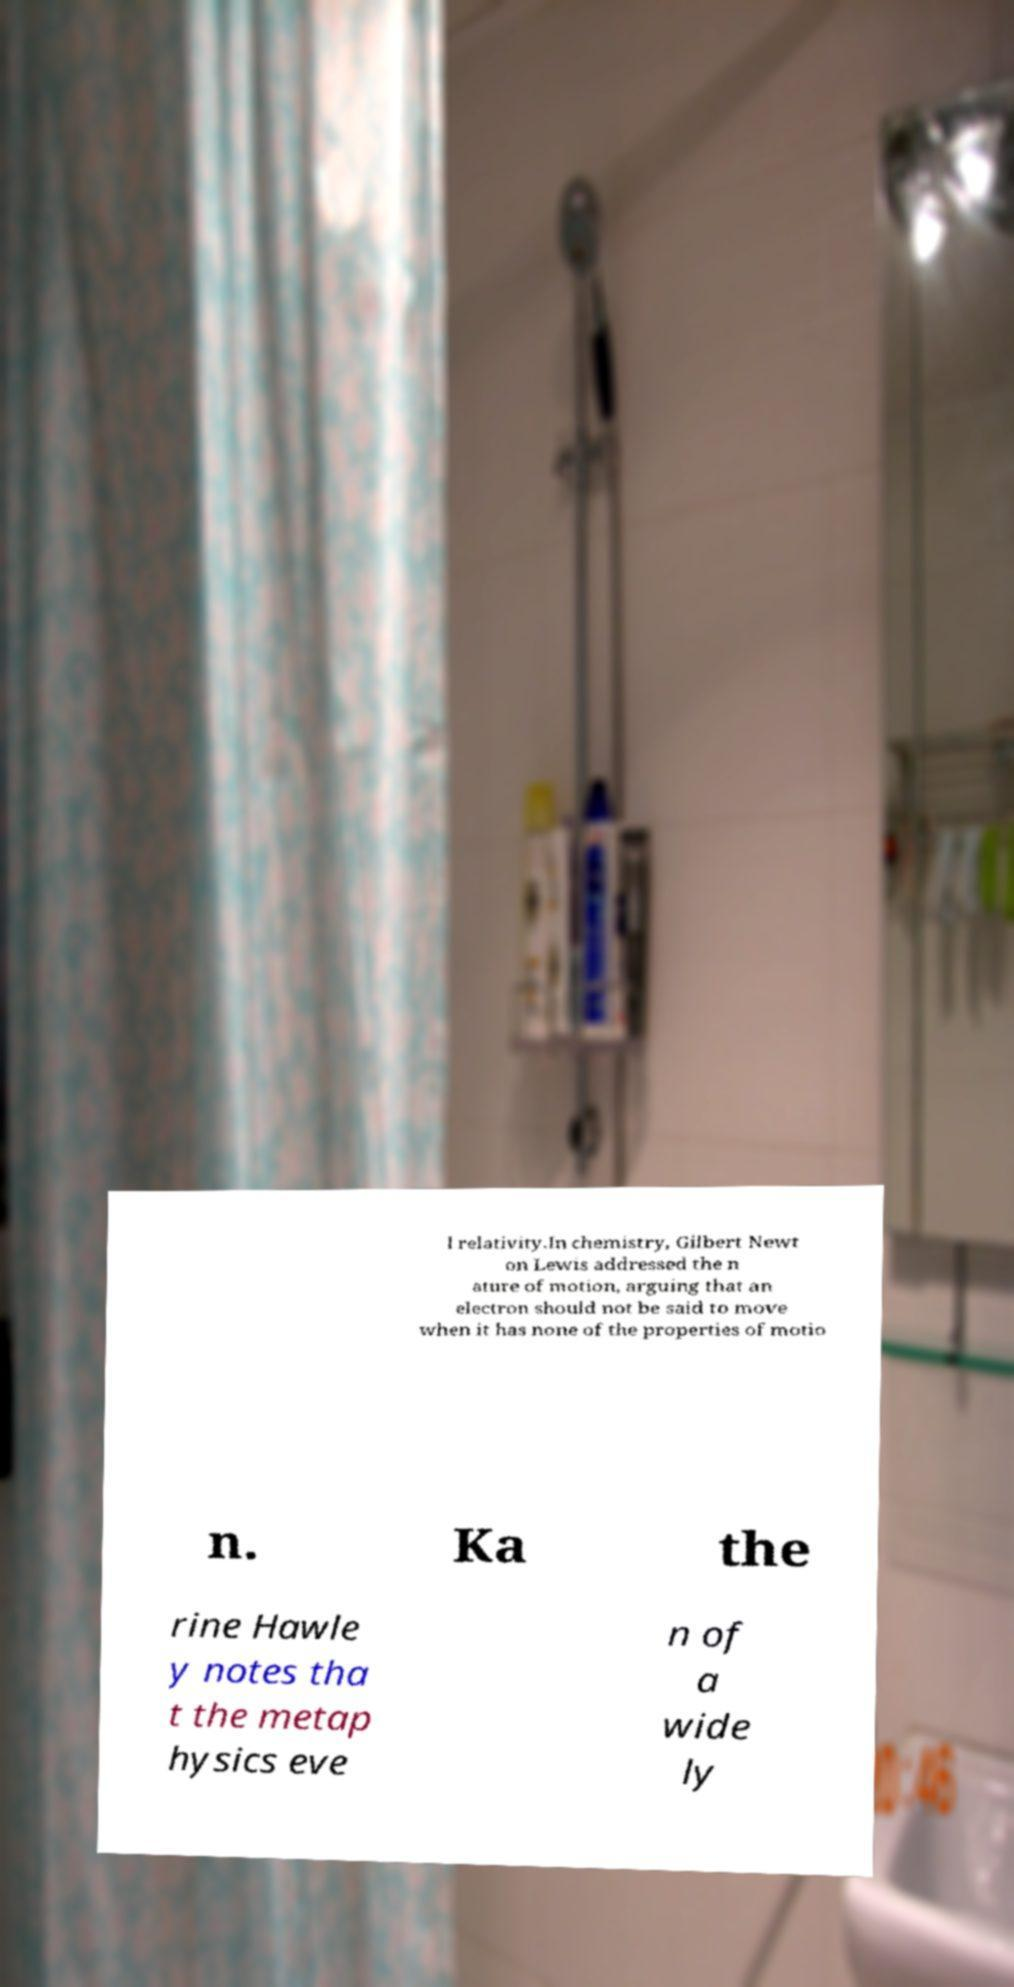For documentation purposes, I need the text within this image transcribed. Could you provide that? l relativity.In chemistry, Gilbert Newt on Lewis addressed the n ature of motion, arguing that an electron should not be said to move when it has none of the properties of motio n. Ka the rine Hawle y notes tha t the metap hysics eve n of a wide ly 